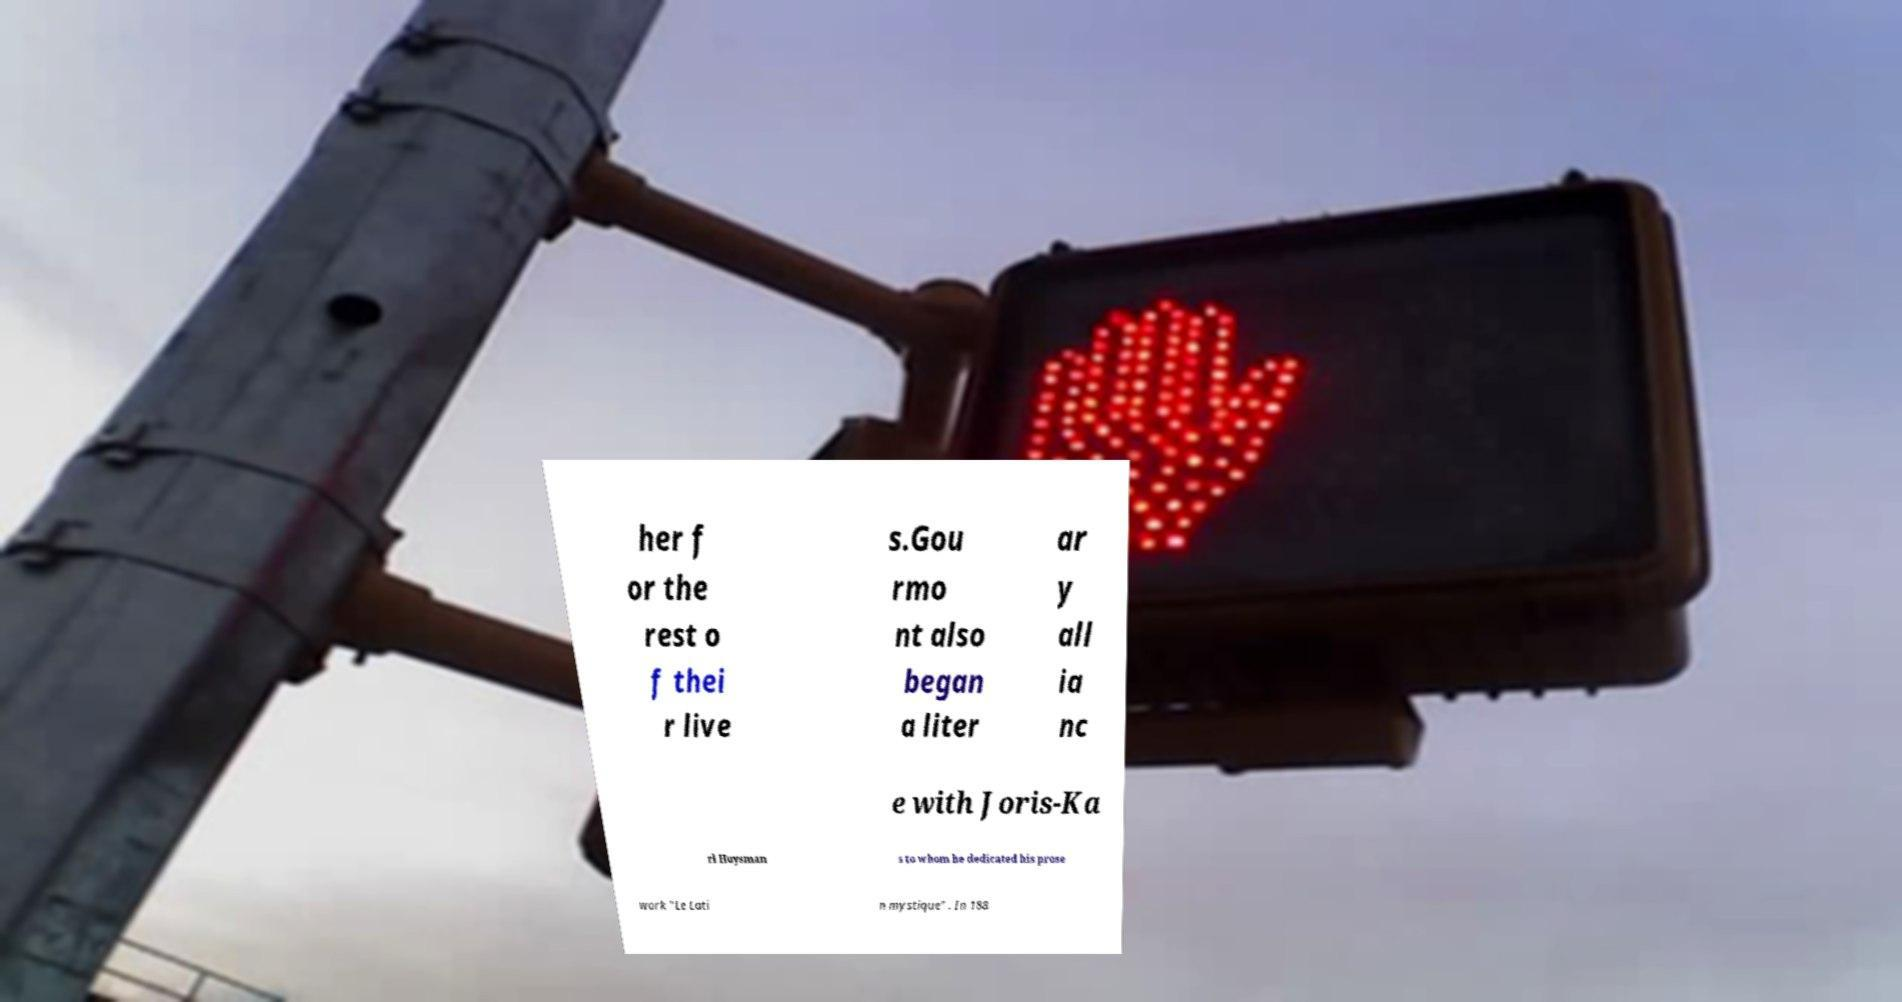Could you extract and type out the text from this image? her f or the rest o f thei r live s.Gou rmo nt also began a liter ar y all ia nc e with Joris-Ka rl Huysman s to whom he dedicated his prose work "Le Lati n mystique" . In 188 